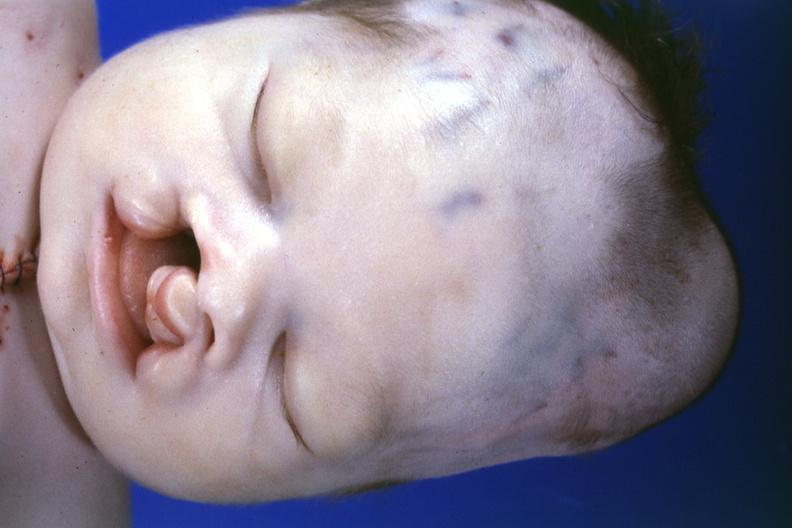s cephalohematoma present?
Answer the question using a single word or phrase. Yes 